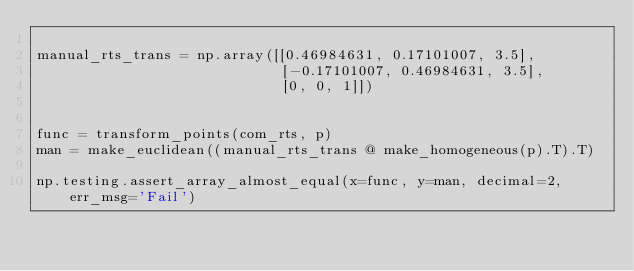<code> <loc_0><loc_0><loc_500><loc_500><_Python_>
manual_rts_trans = np.array([[0.46984631, 0.17101007, 3.5],
                             [-0.17101007, 0.46984631, 3.5],
                             [0, 0, 1]])


func = transform_points(com_rts, p)
man = make_euclidean((manual_rts_trans @ make_homogeneous(p).T).T)

np.testing.assert_array_almost_equal(x=func, y=man, decimal=2, err_msg='Fail')</code> 